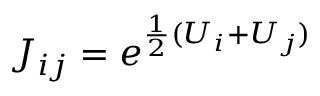<formula> <loc_0><loc_0><loc_500><loc_500>J _ { i j } = e ^ { \frac { 1 } { 2 } ( U _ { i } + U _ { j } ) }</formula> 